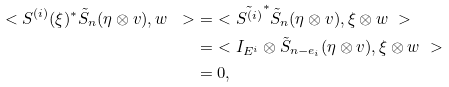<formula> <loc_0><loc_0><loc_500><loc_500>\ < S ^ { ( i ) } ( \xi ) ^ { * } \tilde { S } _ { n } ( \eta \otimes v ) , w \ > & = \ < \tilde { S ^ { ( i ) } } ^ { * } \tilde { S } _ { n } ( \eta \otimes v ) , \xi \otimes w \ > \\ & = \ < I _ { E ^ { i } } \otimes \tilde { S } _ { n - e _ { i } } ( \eta \otimes v ) , \xi \otimes w \ > \\ & = 0 ,</formula> 